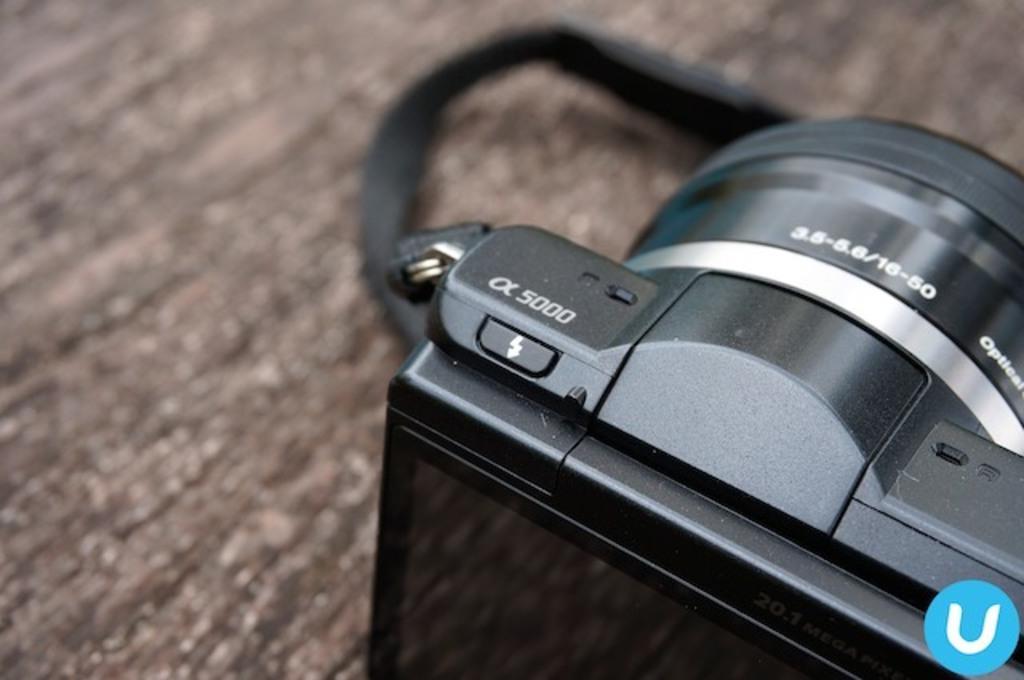How would you summarize this image in a sentence or two? In this image we can see a camera on the table and a logo on the image. 